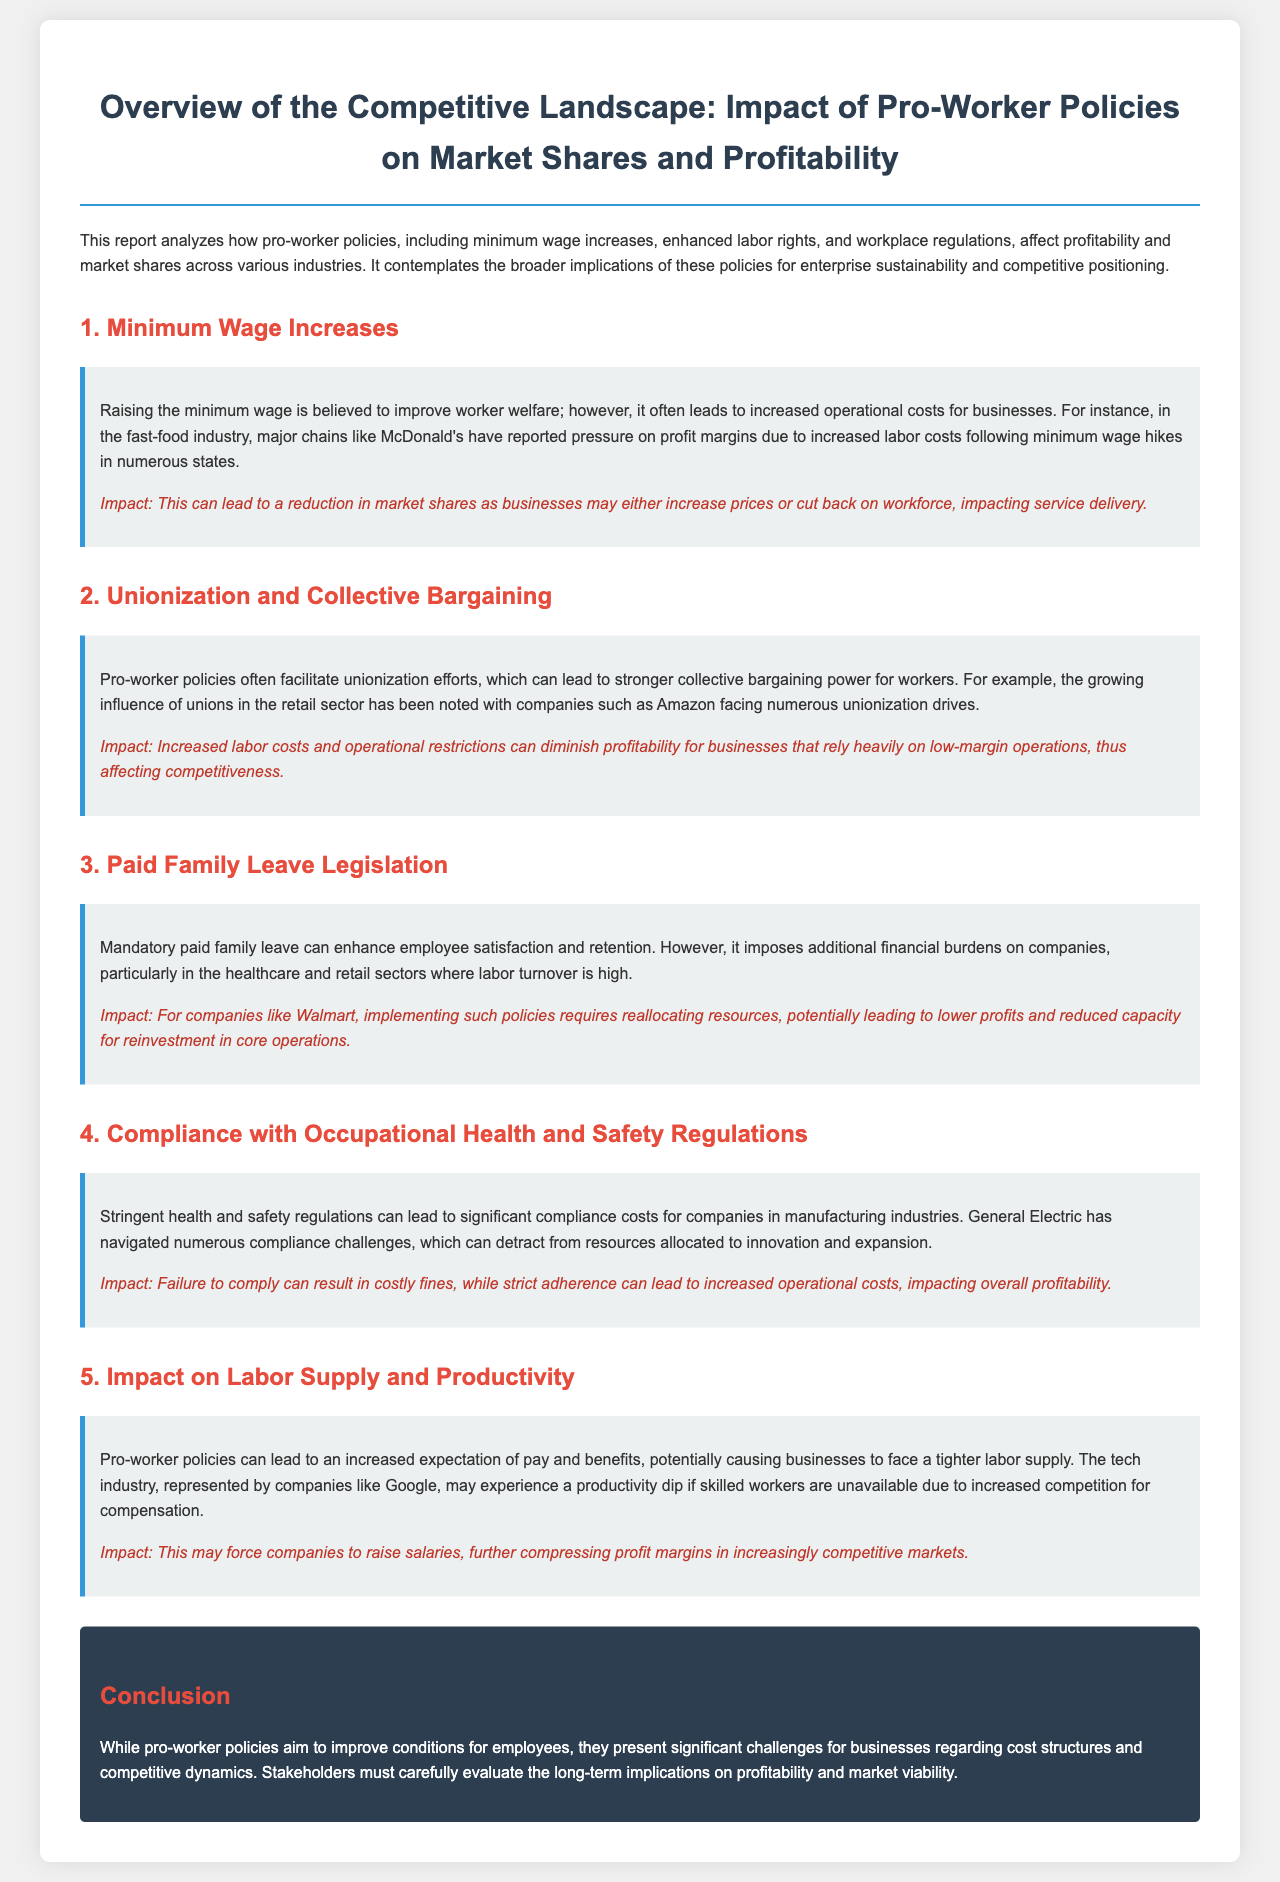What are pro-worker policies? Pro-worker policies include various regulations aimed at improving workers' conditions, such as minimum wage increases and enhanced labor rights.
Answer: Minimum wage increases, enhanced labor rights, and workplace regulations What industry faces profit margin pressure due to minimum wage hikes? The fast-food industry experiences profit margin pressure as major chains report increased labor costs.
Answer: Fast-food industry Which company is mentioned in relation to compliance costs with health and safety regulations? General Electric is highlighted for navigating compliance challenges in manufacturing industries, affecting their resources.
Answer: General Electric What impact do mandatory paid family leave policies have on companies like Walmart? Implementing such policies requires reallocating resources, potentially leading to lower profits and reduced capacity for reinvestment.
Answer: Lower profits How do pro-worker policies affect the labor supply in the tech industry? Increased expectations for pay and benefits may cause a tighter labor supply, impacting employee availability.
Answer: Tighter labor supply What is a significant consequence of increased unionization efforts in the retail sector? Increased labor costs and operational restrictions can diminish profitability for low-margin operations.
Answer: Diminished profitability What is the overall conclusion regarding pro-worker policies in the report? The conclusion states that pro-worker policies present challenges for businesses regarding cost structures and profitability.
Answer: Challenges for businesses Which company is facing unionization drives as mentioned in the document? Amazon is noted for facing numerous unionization drives, reflecting the growing influence of unions in the retail sector.
Answer: Amazon 